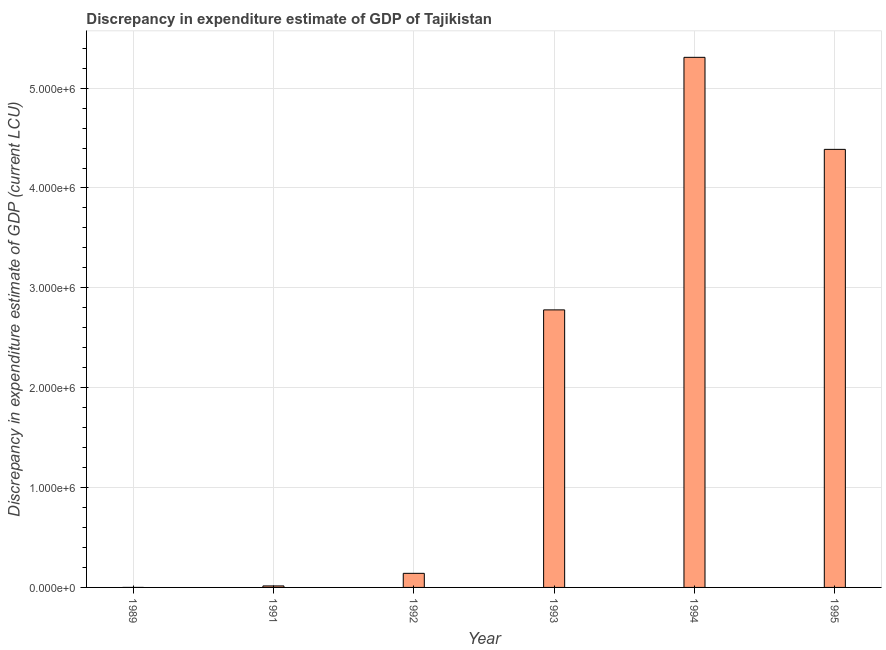Does the graph contain grids?
Offer a very short reply. Yes. What is the title of the graph?
Your response must be concise. Discrepancy in expenditure estimate of GDP of Tajikistan. What is the label or title of the Y-axis?
Ensure brevity in your answer.  Discrepancy in expenditure estimate of GDP (current LCU). What is the discrepancy in expenditure estimate of gdp in 1993?
Provide a succinct answer. 2.78e+06. Across all years, what is the maximum discrepancy in expenditure estimate of gdp?
Make the answer very short. 5.31e+06. Across all years, what is the minimum discrepancy in expenditure estimate of gdp?
Your answer should be compact. 4e-12. What is the sum of the discrepancy in expenditure estimate of gdp?
Give a very brief answer. 1.26e+07. What is the difference between the discrepancy in expenditure estimate of gdp in 1989 and 1994?
Provide a short and direct response. -5.31e+06. What is the average discrepancy in expenditure estimate of gdp per year?
Your answer should be very brief. 2.11e+06. What is the median discrepancy in expenditure estimate of gdp?
Provide a succinct answer. 1.46e+06. In how many years, is the discrepancy in expenditure estimate of gdp greater than 4400000 LCU?
Offer a terse response. 1. Do a majority of the years between 1993 and 1989 (inclusive) have discrepancy in expenditure estimate of gdp greater than 600000 LCU?
Make the answer very short. Yes. What is the ratio of the discrepancy in expenditure estimate of gdp in 1989 to that in 1993?
Provide a short and direct response. 0. What is the difference between the highest and the second highest discrepancy in expenditure estimate of gdp?
Offer a very short reply. 9.22e+05. What is the difference between the highest and the lowest discrepancy in expenditure estimate of gdp?
Your answer should be compact. 5.31e+06. In how many years, is the discrepancy in expenditure estimate of gdp greater than the average discrepancy in expenditure estimate of gdp taken over all years?
Provide a short and direct response. 3. What is the difference between two consecutive major ticks on the Y-axis?
Ensure brevity in your answer.  1.00e+06. Are the values on the major ticks of Y-axis written in scientific E-notation?
Offer a very short reply. Yes. What is the Discrepancy in expenditure estimate of GDP (current LCU) of 1989?
Offer a very short reply. 4e-12. What is the Discrepancy in expenditure estimate of GDP (current LCU) of 1991?
Provide a short and direct response. 1.49e+04. What is the Discrepancy in expenditure estimate of GDP (current LCU) in 1992?
Your answer should be compact. 1.41e+05. What is the Discrepancy in expenditure estimate of GDP (current LCU) of 1993?
Your answer should be compact. 2.78e+06. What is the Discrepancy in expenditure estimate of GDP (current LCU) in 1994?
Give a very brief answer. 5.31e+06. What is the Discrepancy in expenditure estimate of GDP (current LCU) of 1995?
Your answer should be very brief. 4.39e+06. What is the difference between the Discrepancy in expenditure estimate of GDP (current LCU) in 1989 and 1991?
Offer a very short reply. -1.49e+04. What is the difference between the Discrepancy in expenditure estimate of GDP (current LCU) in 1989 and 1992?
Make the answer very short. -1.41e+05. What is the difference between the Discrepancy in expenditure estimate of GDP (current LCU) in 1989 and 1993?
Offer a very short reply. -2.78e+06. What is the difference between the Discrepancy in expenditure estimate of GDP (current LCU) in 1989 and 1994?
Your response must be concise. -5.31e+06. What is the difference between the Discrepancy in expenditure estimate of GDP (current LCU) in 1989 and 1995?
Keep it short and to the point. -4.39e+06. What is the difference between the Discrepancy in expenditure estimate of GDP (current LCU) in 1991 and 1992?
Offer a very short reply. -1.26e+05. What is the difference between the Discrepancy in expenditure estimate of GDP (current LCU) in 1991 and 1993?
Your response must be concise. -2.76e+06. What is the difference between the Discrepancy in expenditure estimate of GDP (current LCU) in 1991 and 1994?
Give a very brief answer. -5.29e+06. What is the difference between the Discrepancy in expenditure estimate of GDP (current LCU) in 1991 and 1995?
Provide a short and direct response. -4.37e+06. What is the difference between the Discrepancy in expenditure estimate of GDP (current LCU) in 1992 and 1993?
Offer a very short reply. -2.64e+06. What is the difference between the Discrepancy in expenditure estimate of GDP (current LCU) in 1992 and 1994?
Provide a short and direct response. -5.17e+06. What is the difference between the Discrepancy in expenditure estimate of GDP (current LCU) in 1992 and 1995?
Your answer should be compact. -4.25e+06. What is the difference between the Discrepancy in expenditure estimate of GDP (current LCU) in 1993 and 1994?
Offer a very short reply. -2.53e+06. What is the difference between the Discrepancy in expenditure estimate of GDP (current LCU) in 1993 and 1995?
Offer a terse response. -1.61e+06. What is the difference between the Discrepancy in expenditure estimate of GDP (current LCU) in 1994 and 1995?
Give a very brief answer. 9.22e+05. What is the ratio of the Discrepancy in expenditure estimate of GDP (current LCU) in 1989 to that in 1993?
Ensure brevity in your answer.  0. What is the ratio of the Discrepancy in expenditure estimate of GDP (current LCU) in 1989 to that in 1994?
Offer a terse response. 0. What is the ratio of the Discrepancy in expenditure estimate of GDP (current LCU) in 1991 to that in 1992?
Offer a very short reply. 0.11. What is the ratio of the Discrepancy in expenditure estimate of GDP (current LCU) in 1991 to that in 1993?
Your response must be concise. 0.01. What is the ratio of the Discrepancy in expenditure estimate of GDP (current LCU) in 1991 to that in 1994?
Provide a short and direct response. 0. What is the ratio of the Discrepancy in expenditure estimate of GDP (current LCU) in 1991 to that in 1995?
Your answer should be compact. 0. What is the ratio of the Discrepancy in expenditure estimate of GDP (current LCU) in 1992 to that in 1993?
Offer a terse response. 0.05. What is the ratio of the Discrepancy in expenditure estimate of GDP (current LCU) in 1992 to that in 1994?
Offer a very short reply. 0.03. What is the ratio of the Discrepancy in expenditure estimate of GDP (current LCU) in 1992 to that in 1995?
Ensure brevity in your answer.  0.03. What is the ratio of the Discrepancy in expenditure estimate of GDP (current LCU) in 1993 to that in 1994?
Provide a succinct answer. 0.52. What is the ratio of the Discrepancy in expenditure estimate of GDP (current LCU) in 1993 to that in 1995?
Offer a terse response. 0.63. What is the ratio of the Discrepancy in expenditure estimate of GDP (current LCU) in 1994 to that in 1995?
Give a very brief answer. 1.21. 